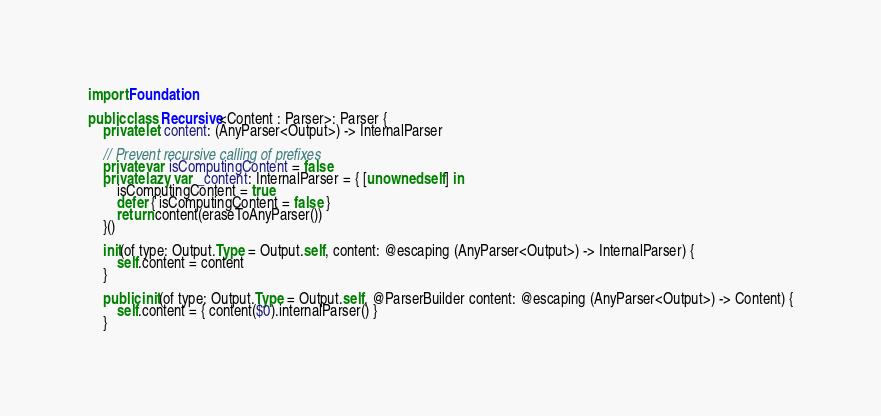<code> <loc_0><loc_0><loc_500><loc_500><_Swift_>
import Foundation

public class Recursive<Content : Parser>: Parser {
    private let content: (AnyParser<Output>) -> InternalParser

    // Prevent recursive calling of prefixes
    private var isComputingContent = false
    private lazy var _content: InternalParser = { [unowned self] in
        isComputingContent = true
        defer { isComputingContent = false }
        return content(eraseToAnyParser())
    }()

    init(of type: Output.Type = Output.self, content: @escaping (AnyParser<Output>) -> InternalParser) {
        self.content = content
    }

    public init(of type: Output.Type = Output.self, @ParserBuilder content: @escaping (AnyParser<Output>) -> Content) {
        self.content = { content($0).internalParser() }
    }
</code> 